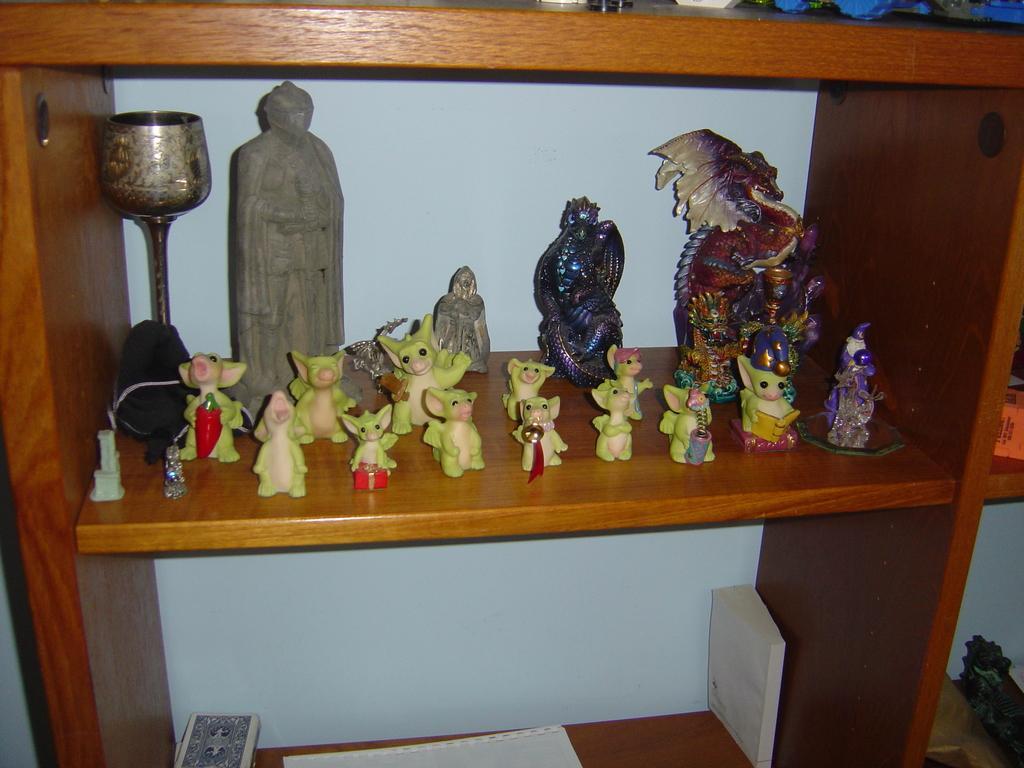In one or two sentences, can you explain what this image depicts? In this image I can see the toys inside the rack. These toys are colorful and the rock is in brown color. I can see few papers and books can be seen in it. 